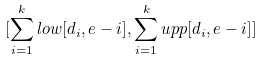Convert formula to latex. <formula><loc_0><loc_0><loc_500><loc_500>[ \sum _ { i = 1 } ^ { k } l o w [ d _ { i } , e - i ] , \sum _ { i = 1 } ^ { k } u p p [ d _ { i } , e - i ] ]</formula> 